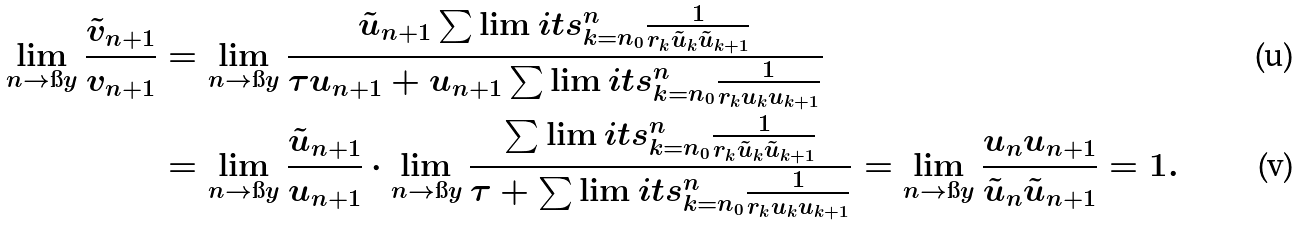<formula> <loc_0><loc_0><loc_500><loc_500>\lim _ { n \to \i y } \frac { \tilde { v } _ { n + 1 } } { v _ { n + 1 } } & = \lim _ { n \to \i y } \frac { \tilde { u } _ { n + 1 } \sum \lim i t s _ { k = n _ { 0 } } ^ { n } \frac { 1 } { r _ { k } \tilde { u } _ { k } \tilde { u } _ { k + 1 } } } { \tau u _ { n + 1 } + u _ { n + 1 } \sum \lim i t s _ { k = n _ { 0 } } ^ { n } \frac { 1 } { r _ { k } u _ { k } u _ { k + 1 } } } \\ & = \lim _ { n \to \i y } \frac { \tilde { u } _ { n + 1 } } { u _ { n + 1 } } \cdot \lim _ { n \to \i y } \frac { \sum \lim i t s _ { k = n _ { 0 } } ^ { n } \frac { 1 } { r _ { k } \tilde { u } _ { k } \tilde { u } _ { k + 1 } } } { \tau + \sum \lim i t s _ { k = n _ { 0 } } ^ { n } \frac { 1 } { r _ { k } u _ { k } u _ { k + 1 } } } = \lim _ { n \to \i y } \frac { u _ { n } u _ { n + 1 } } { \tilde { u } _ { n } \tilde { u } _ { n + 1 } } = 1 .</formula> 